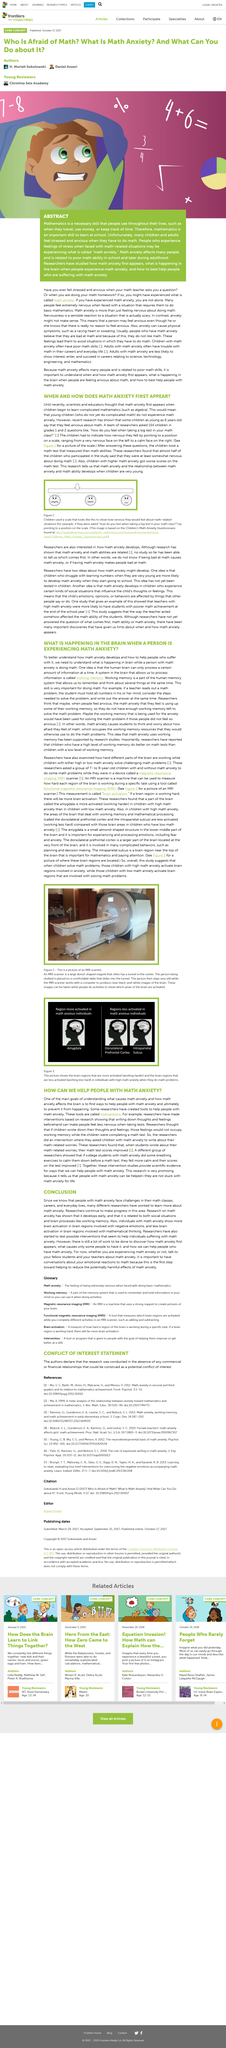Specify some key components in this picture. Before the math test, 154 students from grades 1 and 2 were questioned. It is considered necessary to have proficiency in mathematics. It is a well-known fact that people can experience math anxiety. In the study, children with poorer performance on the test showed a higher level of anxiety on the anxiety scale. Many children and adults experience math anxiety when faced with math-related situations. 